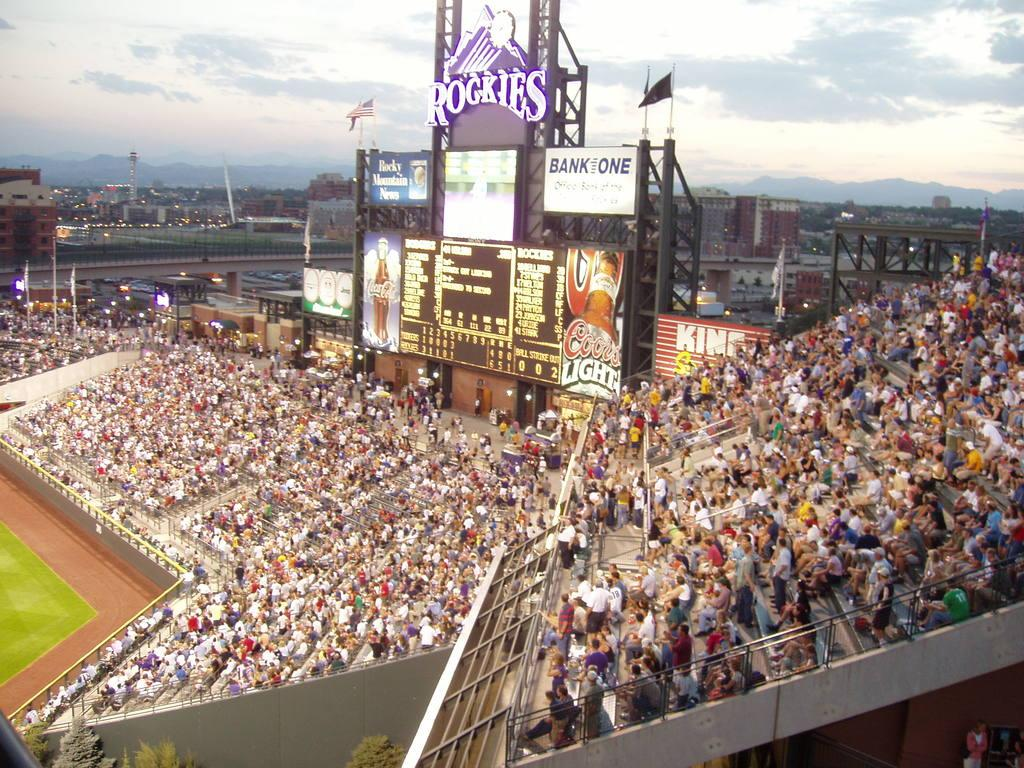<image>
Describe the image concisely. A crowd at the Rockies Game with a Bank One sign 